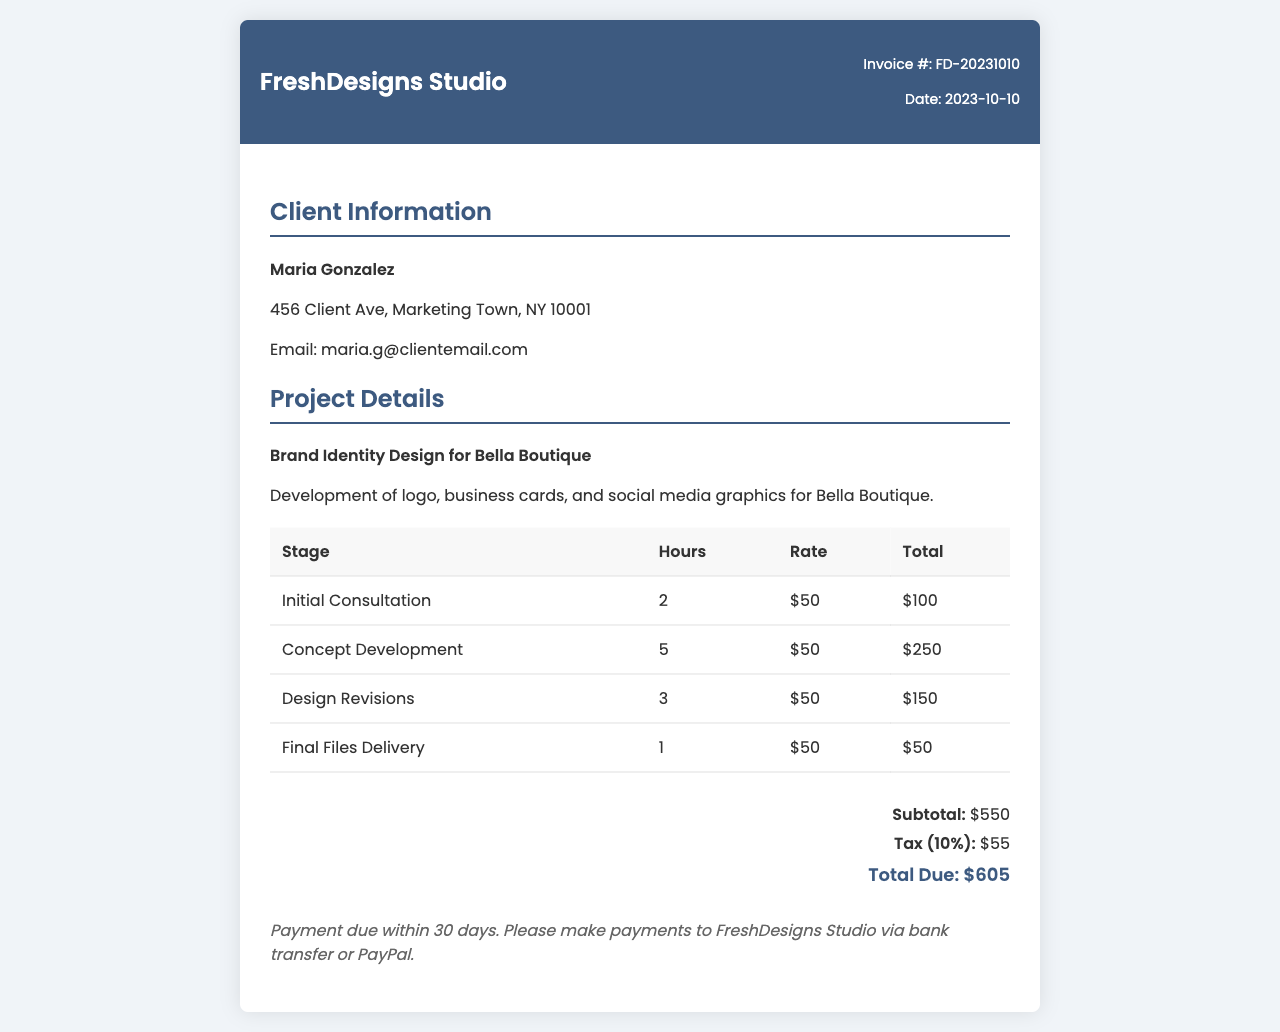What is the invoice number? The invoice number is located in the header section of the document.
Answer: FD-20231010 Who is the client? The client's name is mentioned in the client information section.
Answer: Maria Gonzalez What is the total due amount? The total due amount is provided in the summary section after calculating the subtotal and tax.
Answer: $605 How many hours were spent on concept development? The table lists the hours for each project stage, and concept development has its own entry.
Answer: 5 What is the tax rate used in the invoice? The tax rate is mentioned in the summary section of the invoice.
Answer: 10% What project was worked on? The project details provide the title and brief description of the work done.
Answer: Brand Identity Design for Bella Boutique What payment methods are accepted? The payment terms section describes how payments can be made.
Answer: Bank transfer or PayPal How many stages are listed in the breakdown of project stages? There are entries in the table, each representing a stage of the project.
Answer: 4 When is the payment due? The payment terms section specifies the time frame for payment.
Answer: Within 30 days 